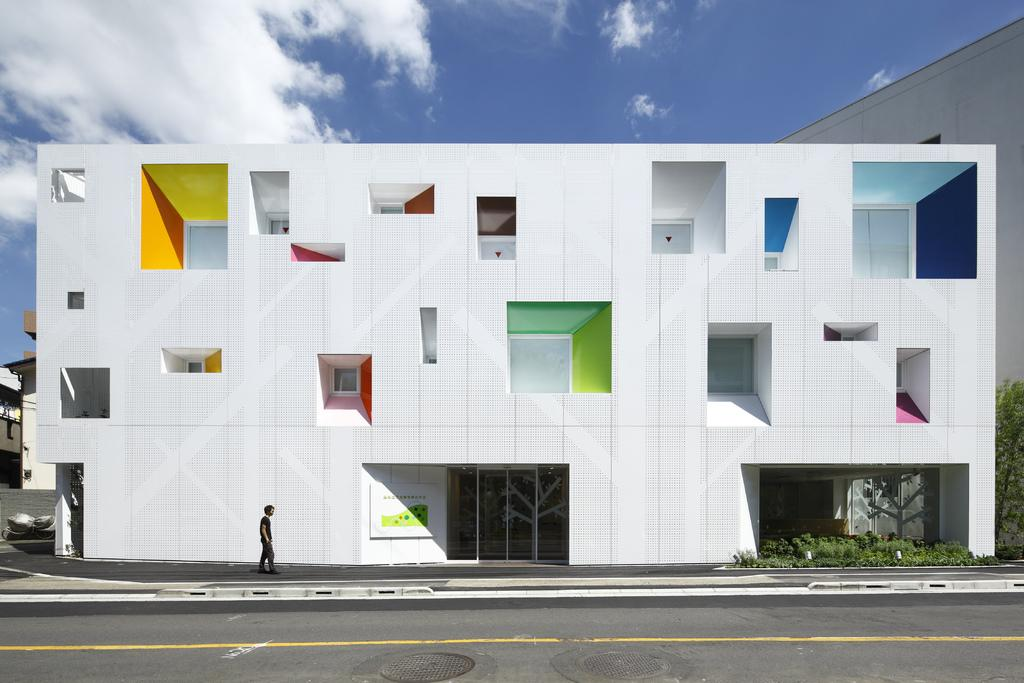What can be seen in the sky in the image? There are clouds in the image. What type of structures are visible in the image? There are buildings in the image. What feature can be found on the buildings in the image? There are windows in the image. What type of vegetation is present in the image? There are plants in the image. Who or what is present in the image? There is a person in the image. Where is the basin located in the image? There is no basin present in the image. What type of fruit is the person holding in the image? The person is not holding any cherries in the image. 